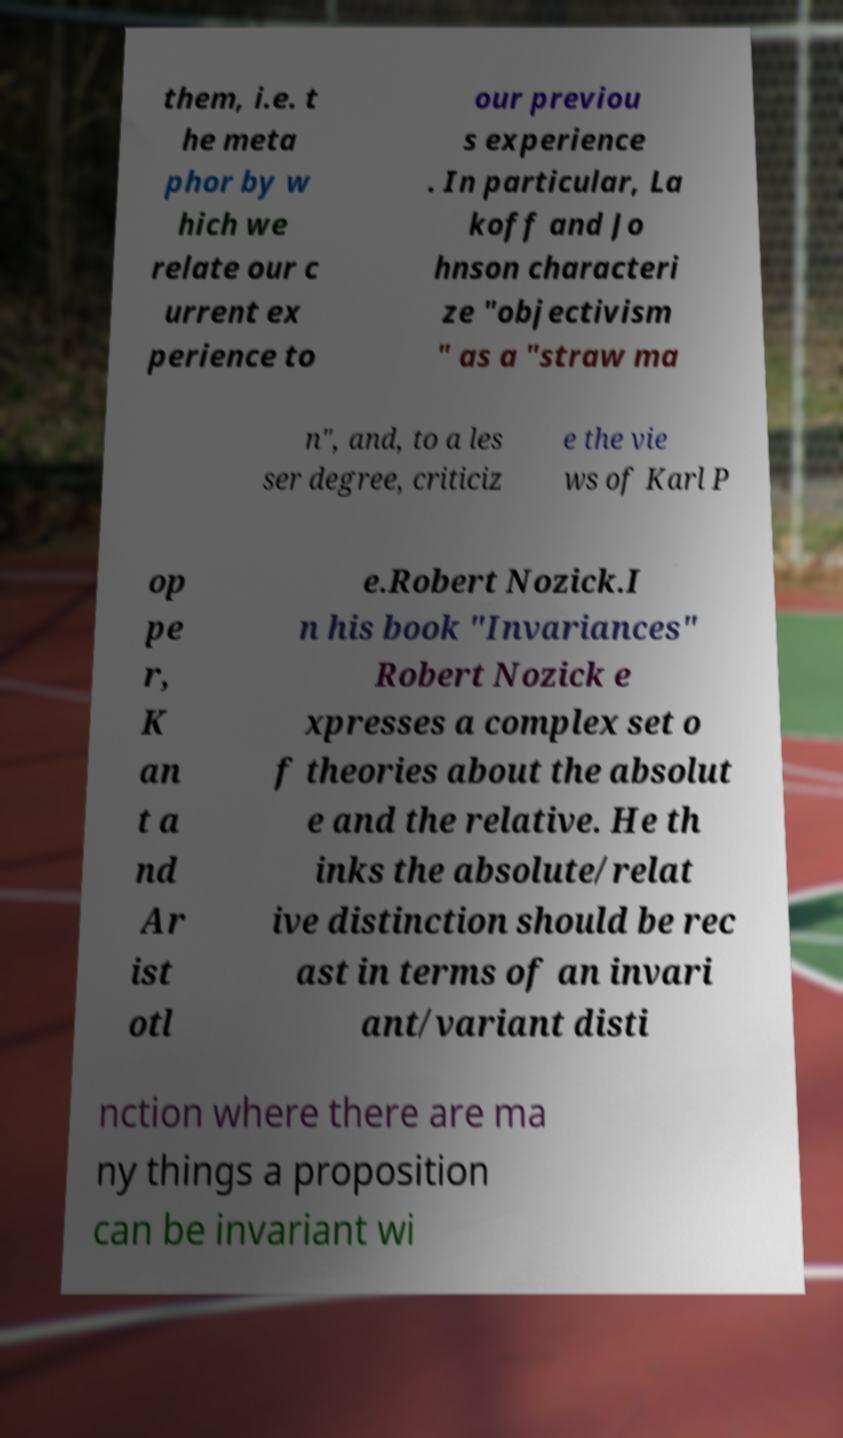Can you accurately transcribe the text from the provided image for me? them, i.e. t he meta phor by w hich we relate our c urrent ex perience to our previou s experience . In particular, La koff and Jo hnson characteri ze "objectivism " as a "straw ma n", and, to a les ser degree, criticiz e the vie ws of Karl P op pe r, K an t a nd Ar ist otl e.Robert Nozick.I n his book "Invariances" Robert Nozick e xpresses a complex set o f theories about the absolut e and the relative. He th inks the absolute/relat ive distinction should be rec ast in terms of an invari ant/variant disti nction where there are ma ny things a proposition can be invariant wi 